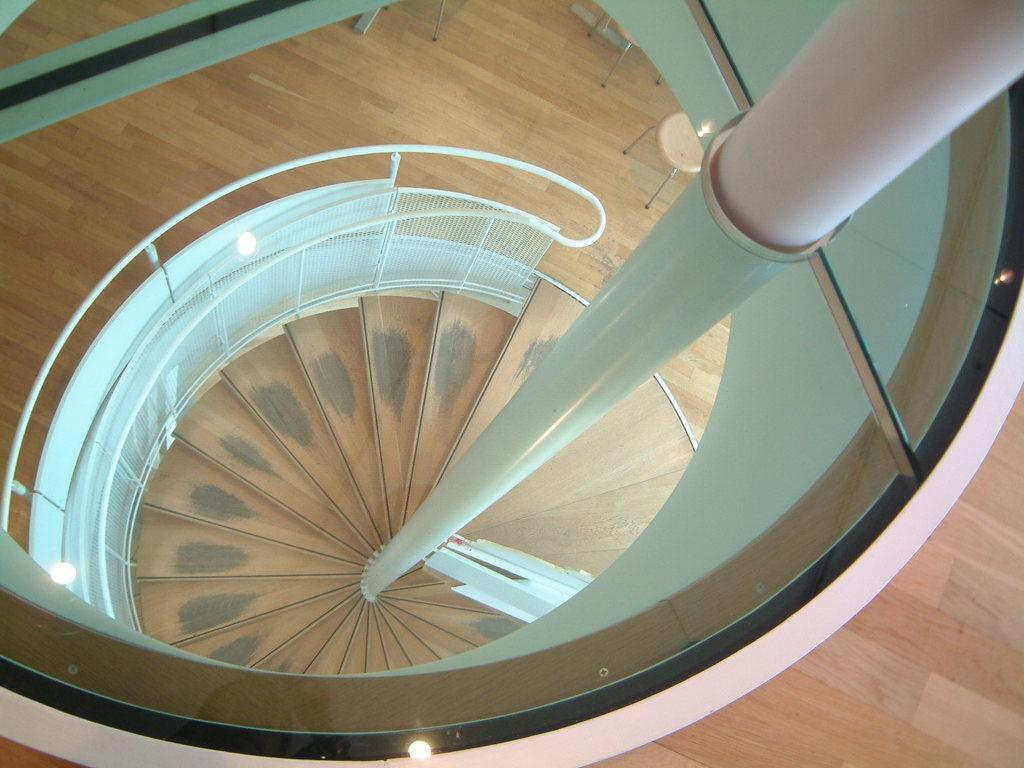What type of structure is present in the image? There are stairs with a handrail in the image. Can you describe another object in the image? There is a pole in the image. What type of furniture can be seen on the wooden floor? There are stools on the wooden floor in the image. What grade does the pet receive for its performance in the image? There is no pet present in the image, so it cannot receive a grade for its performance. 